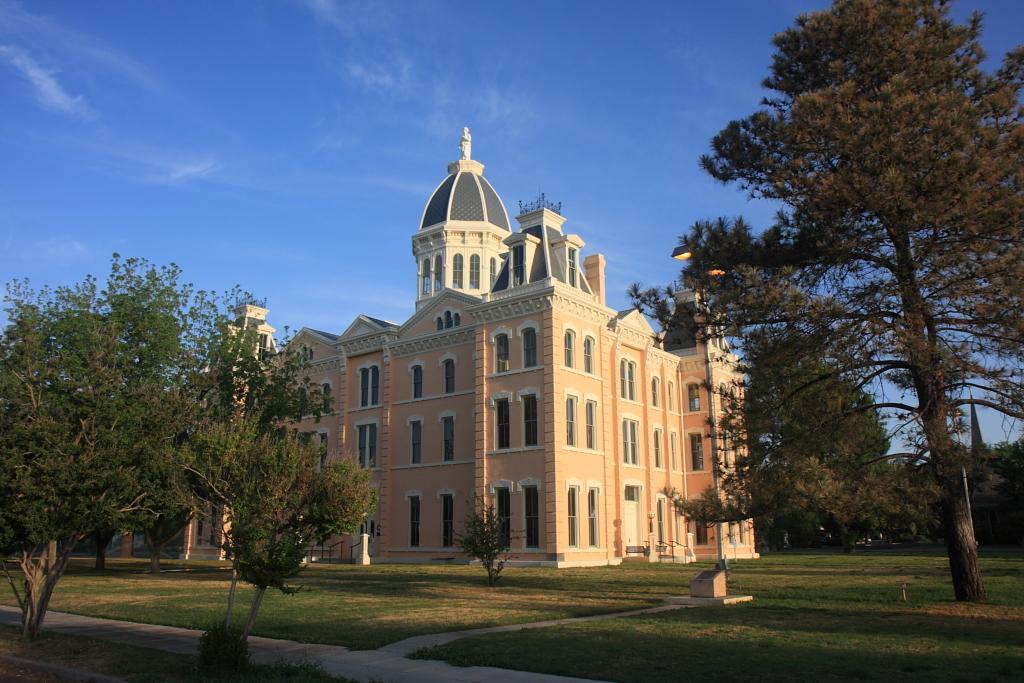How would you summarize this image in a sentence or two? This is an outside view. In the middle of the image there is a building. On the right and left side of the image there are trees. At the bottom, I can see the grass on the ground. At the top of the image I can see the sky in blue color. 